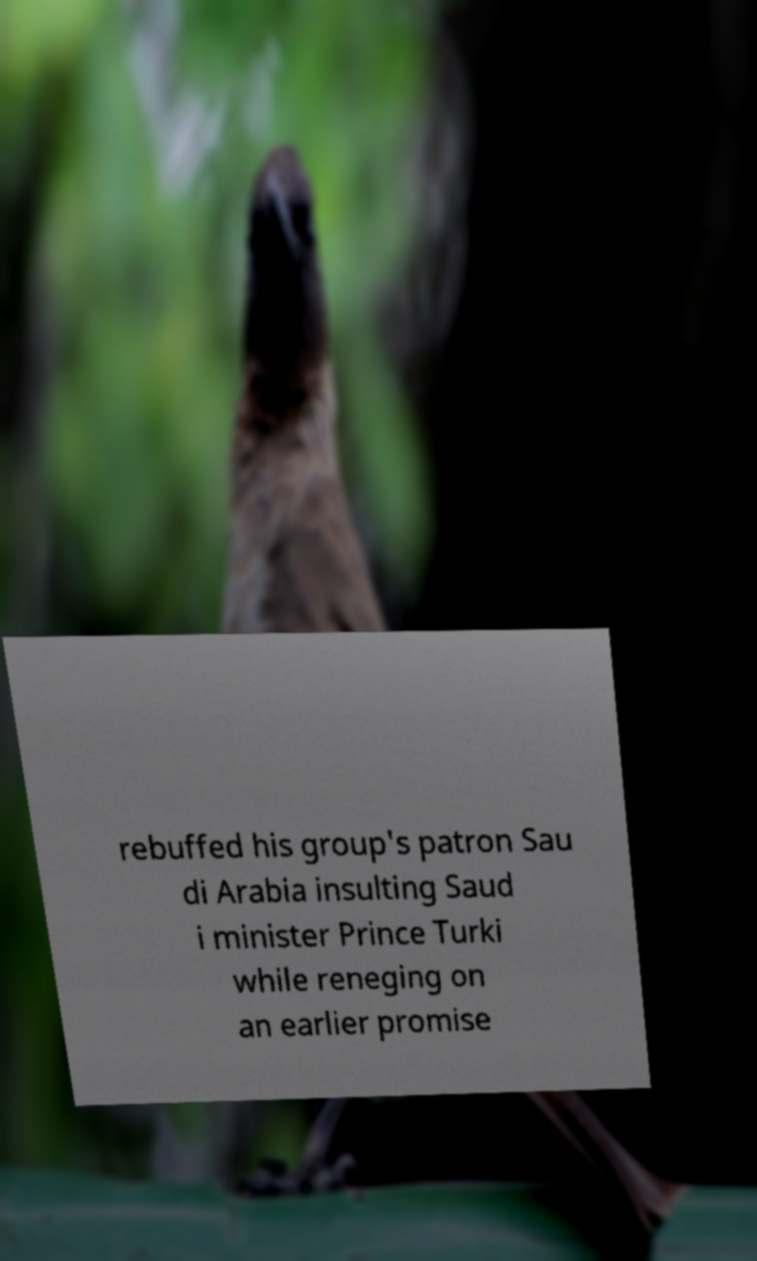There's text embedded in this image that I need extracted. Can you transcribe it verbatim? rebuffed his group's patron Sau di Arabia insulting Saud i minister Prince Turki while reneging on an earlier promise 